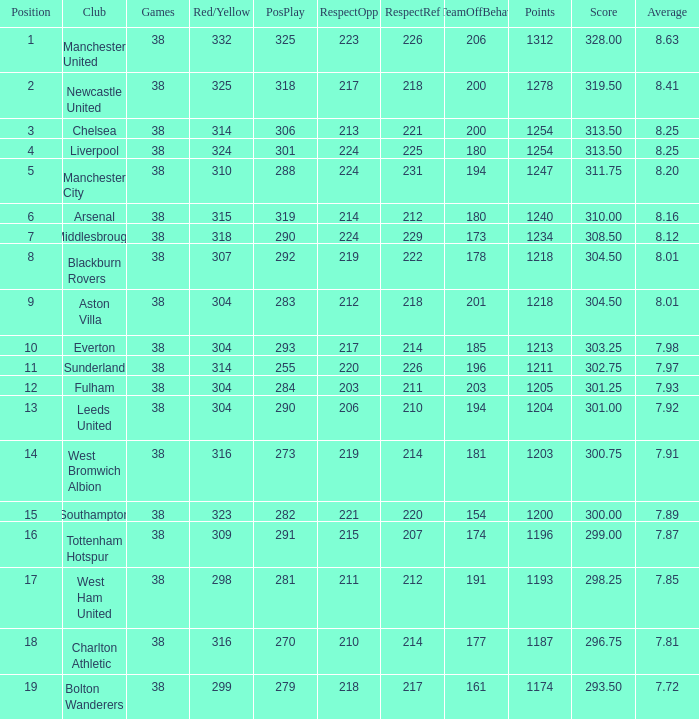Identify the elements of 212 respect when dealing with opponents. 1218.0. 